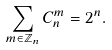Convert formula to latex. <formula><loc_0><loc_0><loc_500><loc_500>\sum _ { m \in \mathbb { Z } _ { n } } C _ { n } ^ { m } = 2 ^ { n } .</formula> 